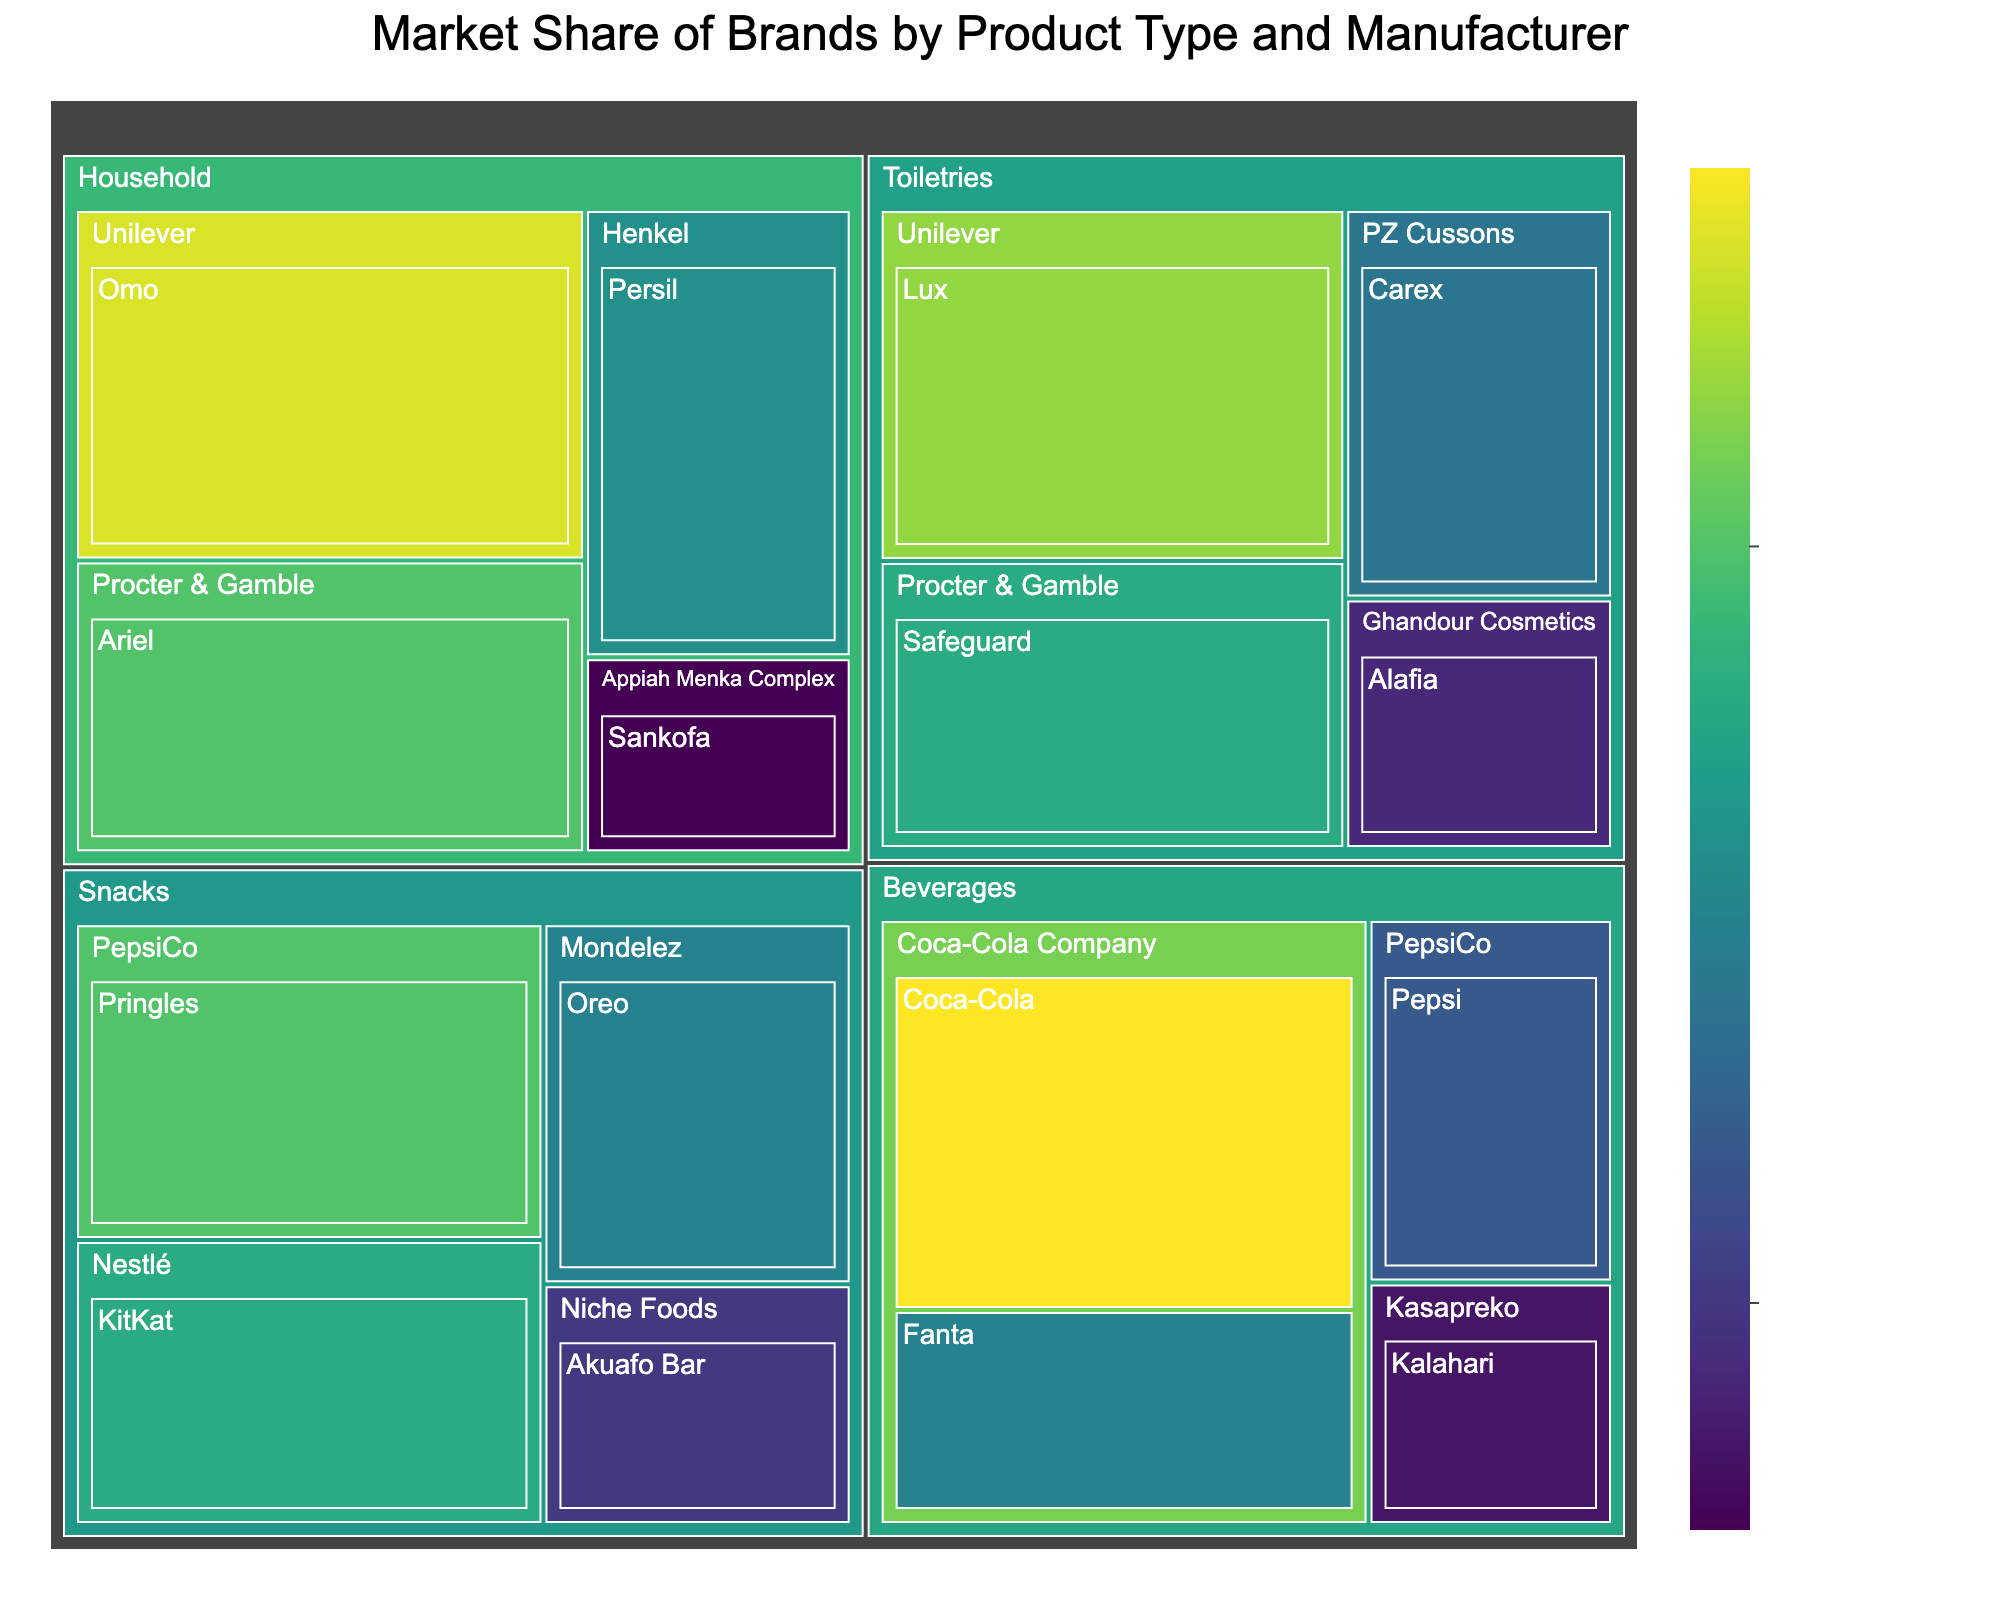What is the title of the Treemap figure? The title of a figure is usually displayed at the top of the treemap. It provides an overview or the main topic of the visual representation. In this case, it would be visible at the top center.
Answer: Market Share of Brands by Product Type and Manufacturer Which beverage brand has the highest market share? To find this, look at the section for Beverages and identify the brand with the largest area in its section.
Answer: Coca-Cola What is the combined market share of Pringles and KitKat in the Snacks category? First, locate both brands in the Snacks section, and then add their market shares together. Pringles has 20% and KitKat has 18%, so their combined market share is 20% + 18%.
Answer: 38% Among the Household products, which brand has the lowest market share? Check the Household section and compare the market shares of the brands. The brand with the smallest area will have the lowest market share.
Answer: Sankofa How many different manufacturers are represented in the Beverages section? Look at the Beverages section and count the unique names of manufacturers listed.
Answer: 3 Which brand has a larger market share: Safeguard or Lux? Identify the market share values of Safeguard and Lux in the Toiletries section. Compare the numbers to determine which one is larger. Safeguard has 18%, whereas Lux has 22%.
Answer: Lux What is the total market share held by Unilever across all product types? Locate all the brands under Unilever in different sections and sum their market shares. Unilever’s brands are Lux (22%) and Omo (24%).
Answer: 46% Compare the market share of brands in the Toiletries section to determine the average market share in this category. Add the market shares of all brands in the Toiletries category and then divide by the number of brands. Market shares are Lux (22%), Safeguard (18%), Carex (14%), and Alafia (9%). So, (22+18+14+9)/4 = 15.75%.
Answer: 15.75% Which manufacturer has the largest combined market share in the Snacks category? Identify the manufacturers in the Snacks section, sum the market shares of their respective brands, and compare the sums. PepsiCo has Pringles (20%), Nestlé has KitKat (18%), Mondelez has Oreo (15%), and Niche Foods has Akuafo Bar (10%). PepsiCo’s total is 20%.
Answer: PepsiCo What is the market share difference between Ariel and Persil in the Household category? Find the market shares for Ariel and Persil in the Household section and subtract the smaller from the larger. Ariel has 20% and Persil has 16%, so the difference is 20% - 16%.
Answer: 4% 